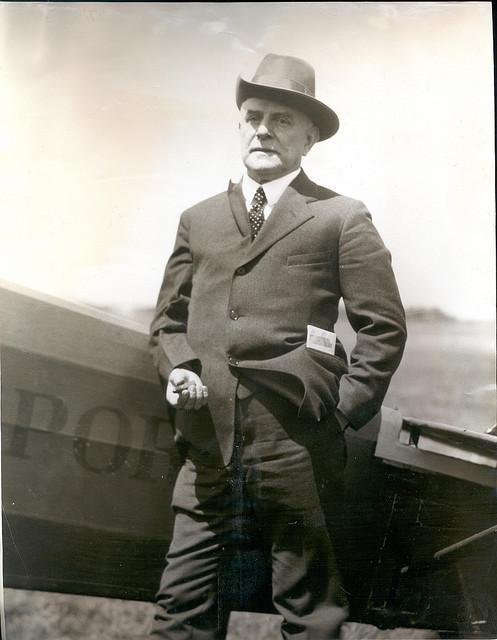Does the description: "The airplane is behind the person." accurately reflect the image?
Answer yes or no. Yes. 